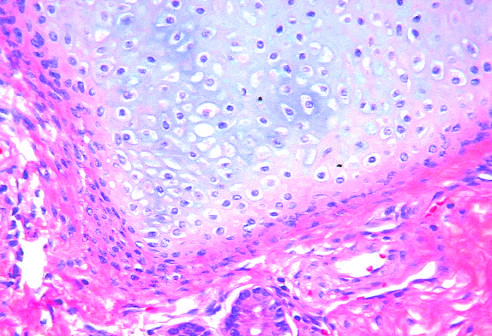what contain mature cells from endodermal, mesodermal, and ectodermal lines?
Answer the question using a single word or phrase. Testicular teratomas 